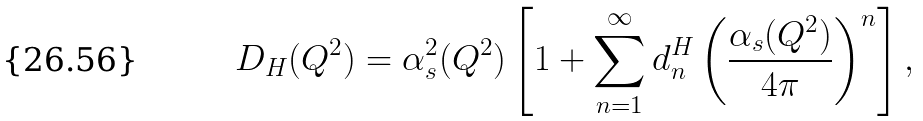Convert formula to latex. <formula><loc_0><loc_0><loc_500><loc_500>D _ { H } ( Q ^ { 2 } ) = \alpha _ { s } ^ { 2 } ( Q ^ { 2 } ) \left [ 1 + \sum _ { n = 1 } ^ { \infty } d _ { n } ^ { H } \left ( \frac { \alpha _ { s } ( Q ^ { 2 } ) } { 4 \pi } \right ) ^ { n } \right ] ,</formula> 